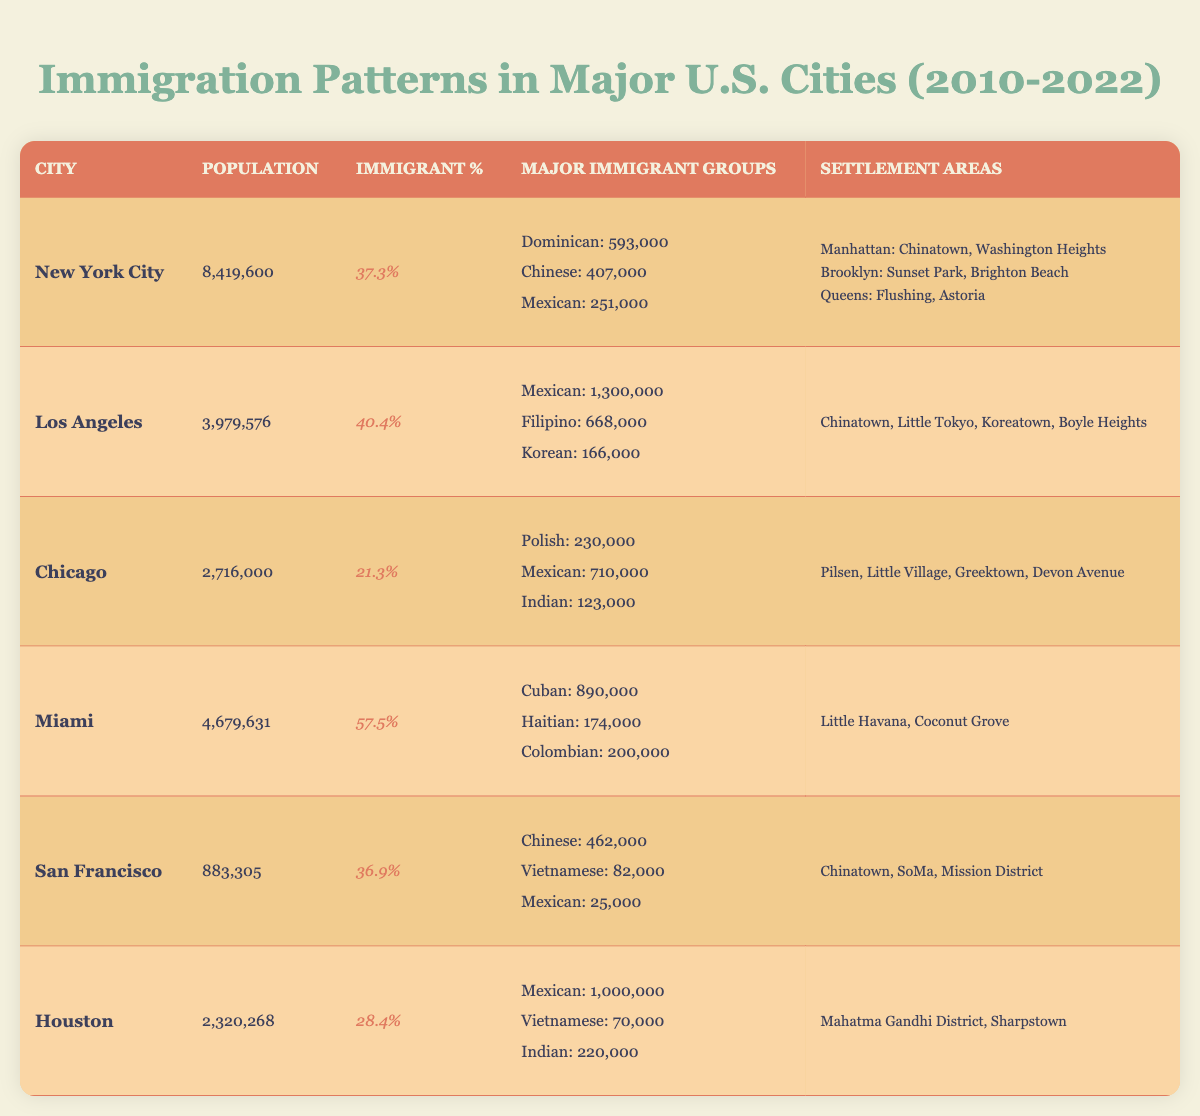What is the immigrant population percentage in Miami? The table shows that Miami has an immigrant population percentage of 57.5%.
Answer: 57.5% Which city has the largest immigrant population among the given cities? By reviewing the major immigrant groups in the table, Los Angeles has the largest immigrant population, with 1,300,000 Mexicans and 668,000 Filipinos, totaling 1,968,000. This is greater than any other city.
Answer: Los Angeles What are the major immigrant groups in Chicago? The major immigrant groups in Chicago, according to the table, are Polish (230,000), Mexican (710,000), and Indian (123,000).
Answer: Polish, Mexican, Indian How many immigrant groups have populations over 500,000 in New York City? In New York City, two immigrant groups have populations over 500,000: Dominican (593,000) and Chinese (407,000). Therefore, there is only one group that exceeds 500,000.
Answer: 1 Which city has the highest percentage of immigrants and what is it? By comparing the immigrant population percentages across the cities, Miami has the highest percentage at 57.5%.
Answer: Miami, 57.5% Is the total immigrant population in San Francisco greater than in Houston? San Francisco has major groups amounting to 462,000 (Chinese), 82,000 (Vietnamese), and 25,000 (Mexican), totaling 569,000. In Houston, the total of 1,000,000 (Mexican), 70,000 (Vietnamese), and 220,000 (Indian) equals 1,290,000. Since 569,000 is less than 1,290,000, the answer is no.
Answer: No Which neighborhood in Los Angeles is known for its Filipino population? The table lists Koreatown as one of the neighborhoods in Los Angeles, which is primarily known for its immigrant communities, but does not specify Filipino. However, it is commonly known that Little Manila exists in the greater Los Angeles area.
Answer: Koreatown If you combine the populations of major immigrant groups in Miami and Chicago, what is the total? The total immigrant populations in Miami (Cuban: 890,000, Haitian: 174,000, Colombian: 200,000, totaling 1,264,000) and Chicago (Polish: 230,000, Mexican: 710,000, Indian: 123,000, totaling 1,063,000) equals 2,327,000.
Answer: 2,327,000 